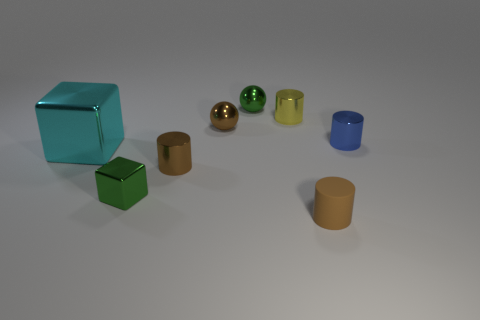What shape is the rubber object that is the same size as the blue shiny object?
Your answer should be compact. Cylinder. There is a small green thing behind the brown shiny ball; are there any small brown cylinders on the left side of it?
Make the answer very short. Yes. What number of tiny objects are brown rubber cylinders or cyan rubber cubes?
Your answer should be very brief. 1. Is there a metallic thing that has the same size as the blue shiny cylinder?
Offer a terse response. Yes. Are there an equal number of small shiny things and large purple matte balls?
Offer a very short reply. No. What number of rubber objects are either cylinders or big red things?
Your answer should be compact. 1. There is a small shiny thing that is the same color as the small metal cube; what is its shape?
Make the answer very short. Sphere. How many yellow objects are there?
Make the answer very short. 1. Are the tiny ball in front of the small green sphere and the tiny green object in front of the large cyan thing made of the same material?
Your response must be concise. Yes. The green cube that is made of the same material as the big thing is what size?
Your answer should be compact. Small. 